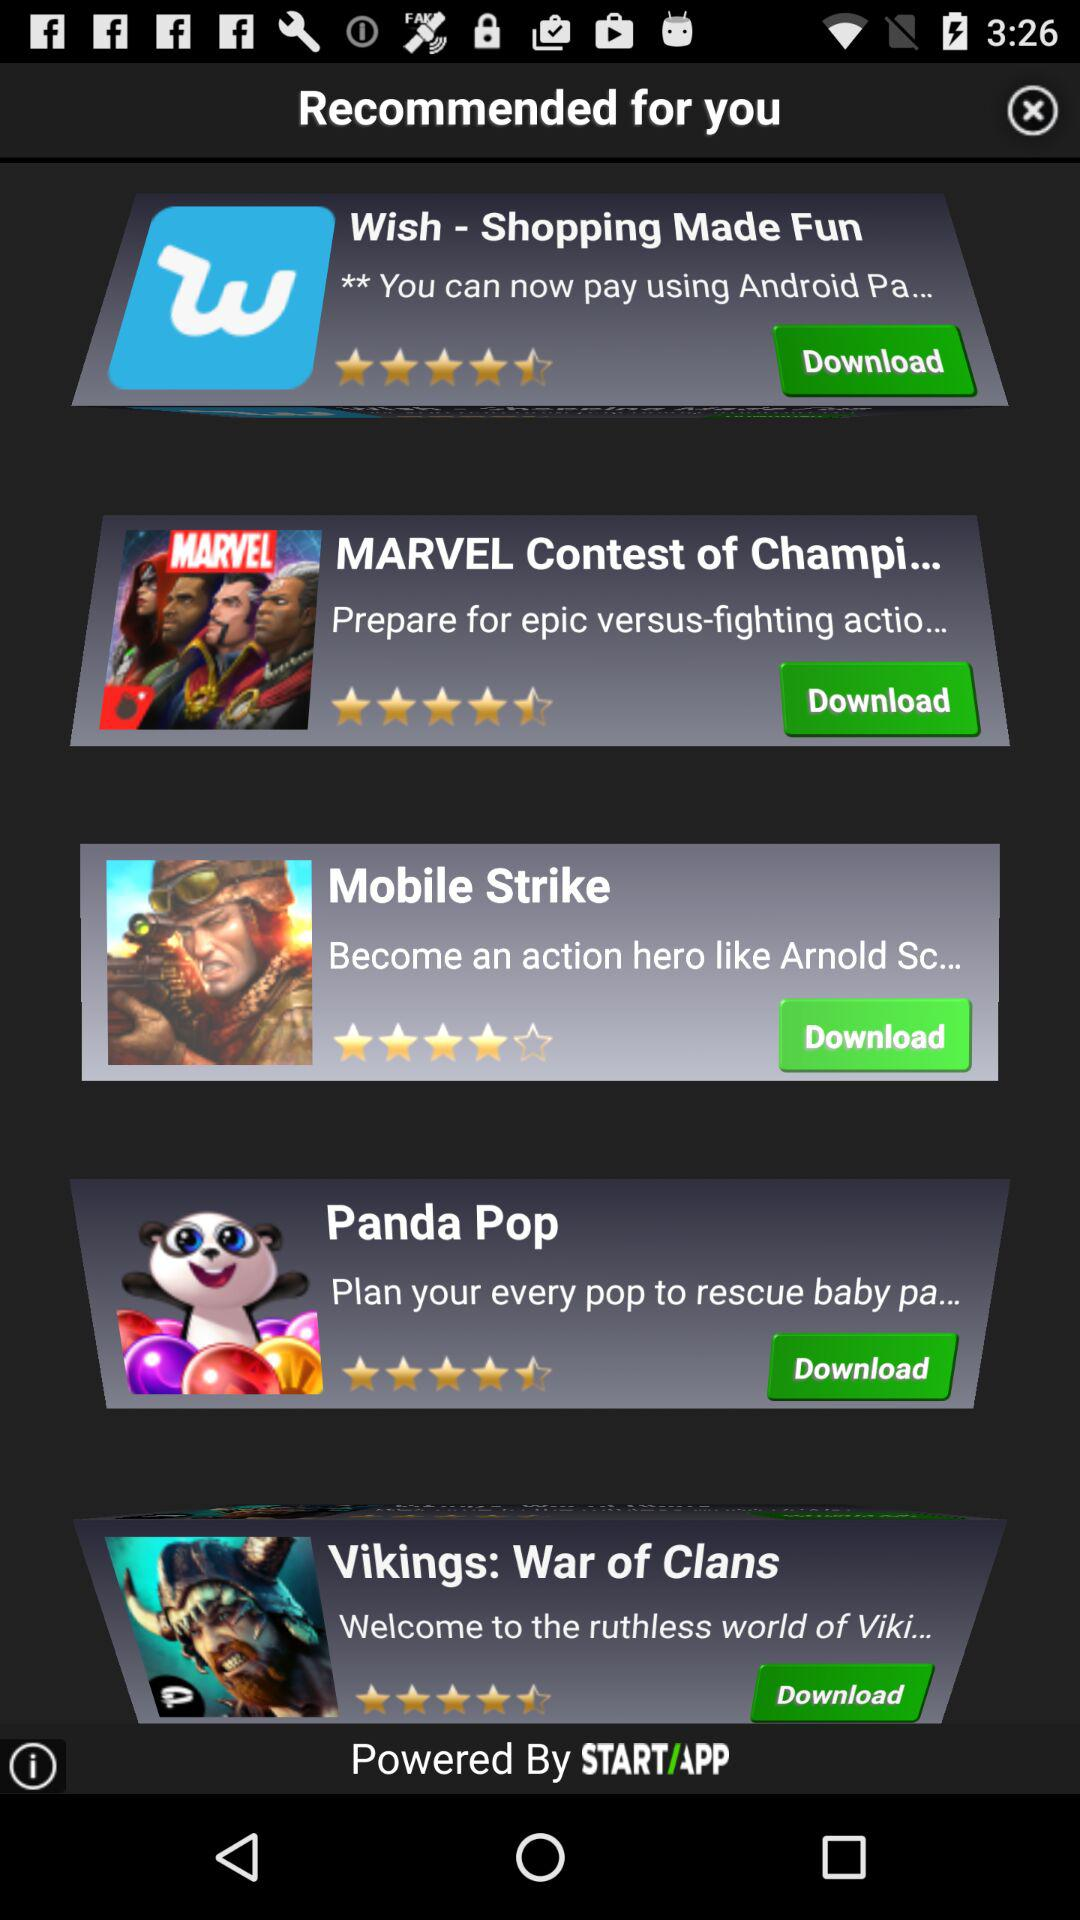What are the applications that are recommended for me? The applications are "Wish - Shopping Made Fun", "MARVEL Contest of Champi...", "Mobile Strike", "Panda Pop" and "Vikings: War of Clans". 